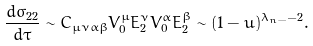Convert formula to latex. <formula><loc_0><loc_0><loc_500><loc_500>& \frac { d \sigma _ { 2 2 } } { d \tau } \sim C _ { \mu \nu \alpha \beta } V ^ { \mu } _ { 0 } E ^ { \nu } _ { 2 } V ^ { \alpha } _ { 0 } E ^ { \beta } _ { 2 } \sim ( 1 - u ) ^ { \lambda _ { n - } - 2 } .</formula> 